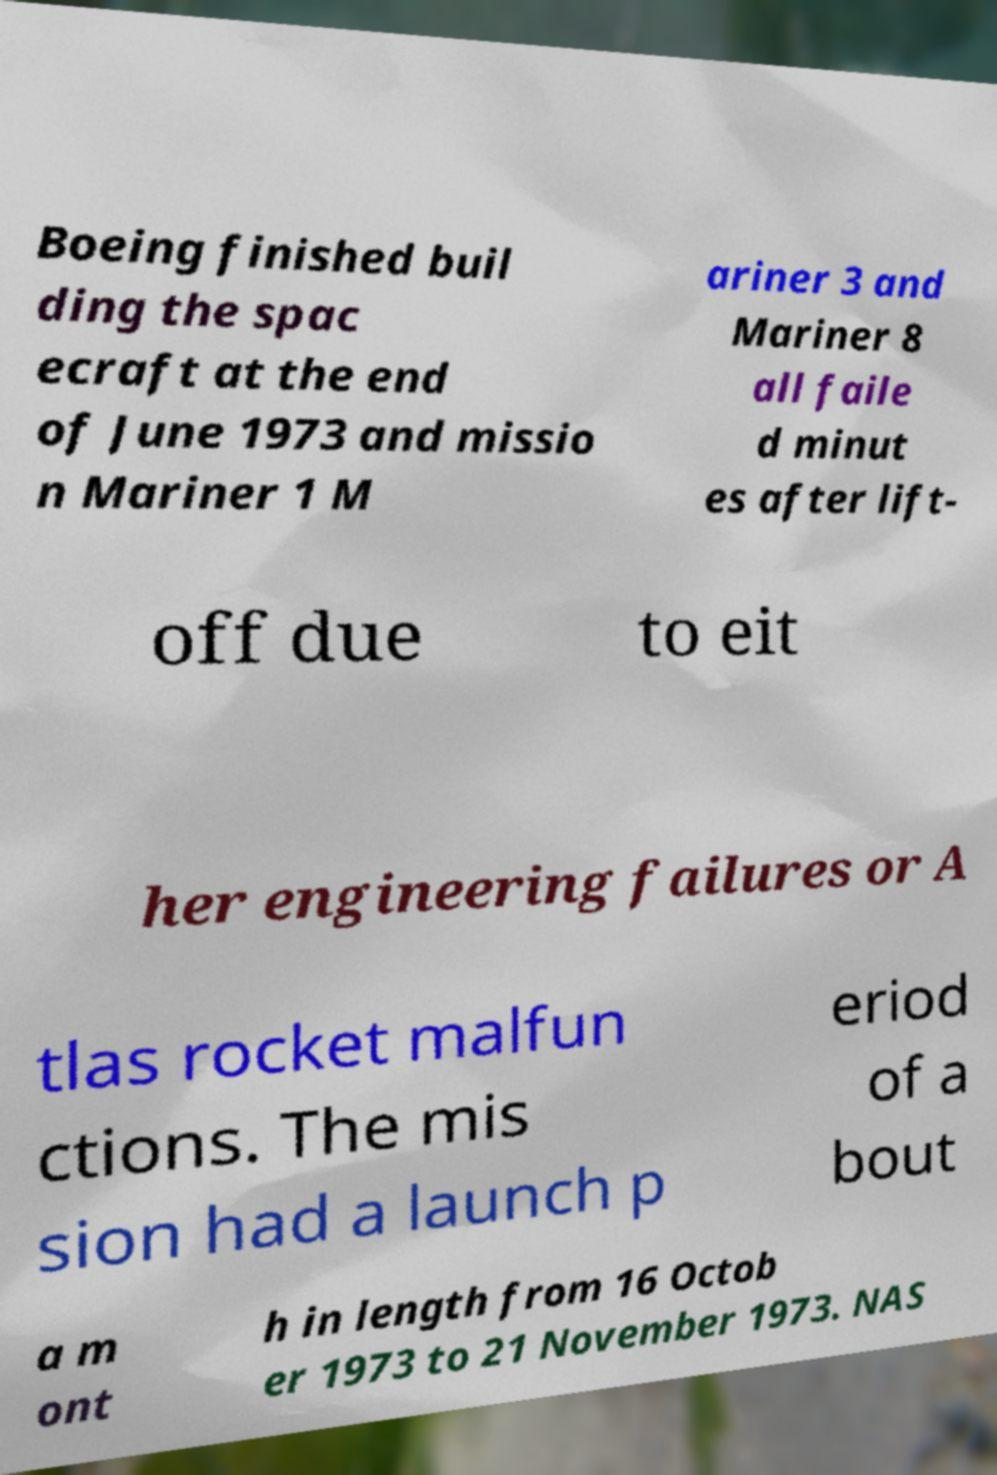I need the written content from this picture converted into text. Can you do that? Boeing finished buil ding the spac ecraft at the end of June 1973 and missio n Mariner 1 M ariner 3 and Mariner 8 all faile d minut es after lift- off due to eit her engineering failures or A tlas rocket malfun ctions. The mis sion had a launch p eriod of a bout a m ont h in length from 16 Octob er 1973 to 21 November 1973. NAS 